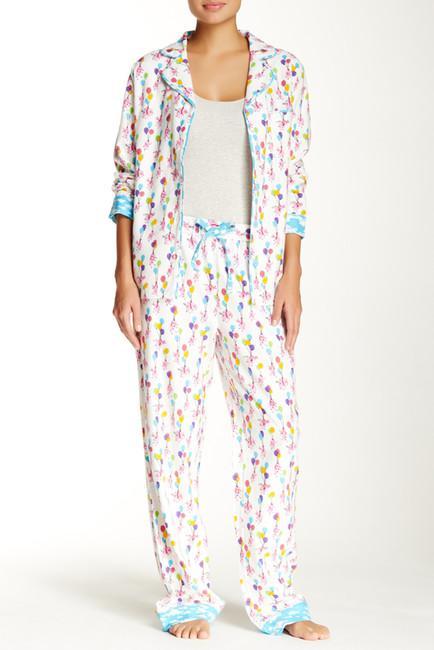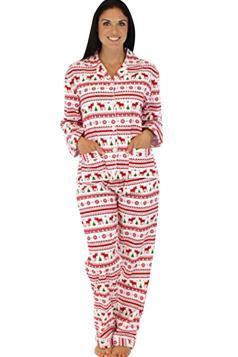The first image is the image on the left, the second image is the image on the right. For the images displayed, is the sentence "The girl on the left is wearing primarily gray pajamas." factually correct? Answer yes or no. No. 